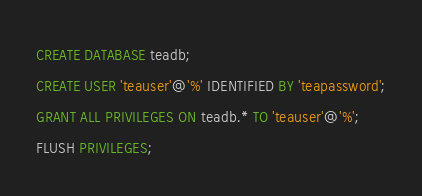<code> <loc_0><loc_0><loc_500><loc_500><_SQL_>CREATE DATABASE teadb;
CREATE USER 'teauser'@'%' IDENTIFIED BY 'teapassword';
GRANT ALL PRIVILEGES ON teadb.* TO 'teauser'@'%';
FLUSH PRIVILEGES;
</code> 